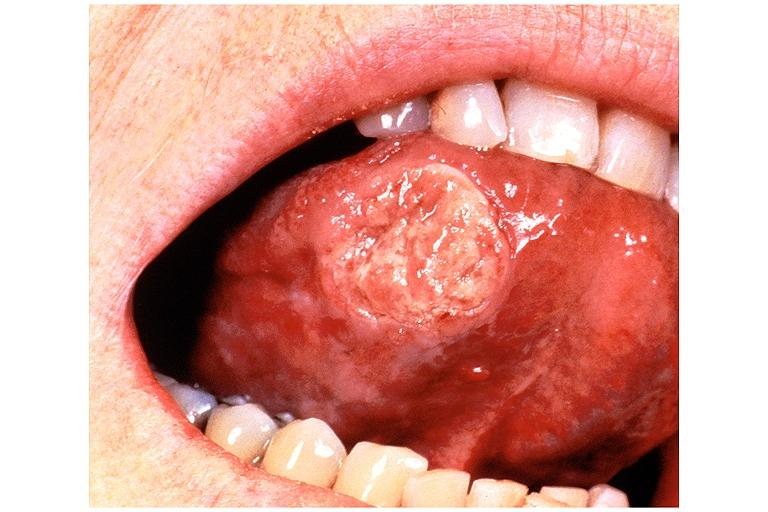does this image show squamous cell carcinoma?
Answer the question using a single word or phrase. Yes 